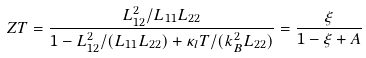Convert formula to latex. <formula><loc_0><loc_0><loc_500><loc_500>Z T = \frac { L _ { 1 2 } ^ { 2 } / L _ { 1 1 } L _ { 2 2 } } { 1 - L _ { 1 2 } ^ { 2 } / ( L _ { 1 1 } L _ { 2 2 } ) + \kappa _ { l } T / ( k _ { B } ^ { 2 } L _ { 2 2 } ) } = \frac { \xi } { 1 - \xi + A }</formula> 